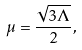Convert formula to latex. <formula><loc_0><loc_0><loc_500><loc_500>\mu = \frac { \sqrt { 3 \Lambda } } { 2 } ,</formula> 